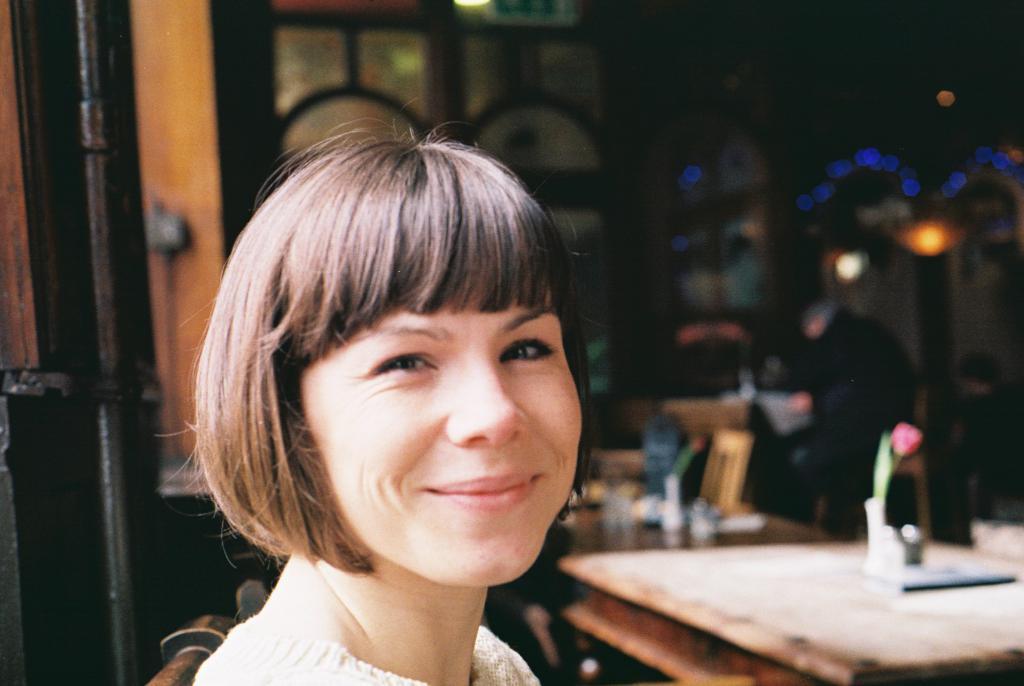In one or two sentences, can you explain what this image depicts? In this picture we can see woman sitting on chair and smiling and in front of her there is table and on table we can see menu card, flower, some items and in background we can see wall, light. 